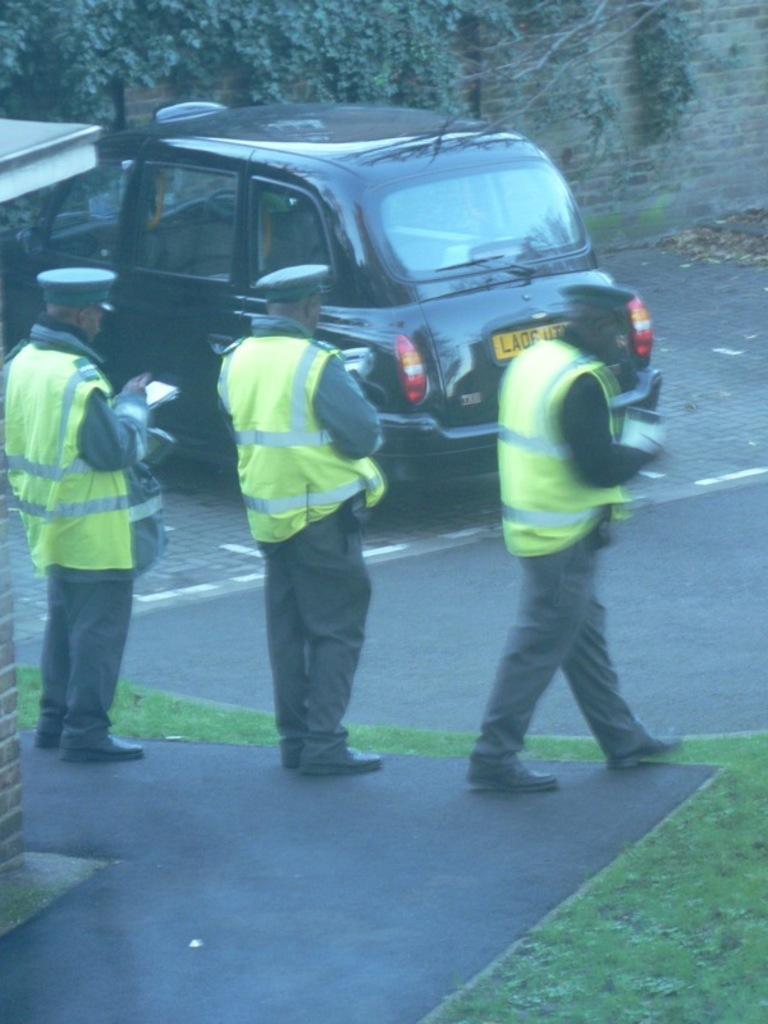Could you give a brief overview of what you see in this image? In this picture we can see a car and 3 policemen on the road. 